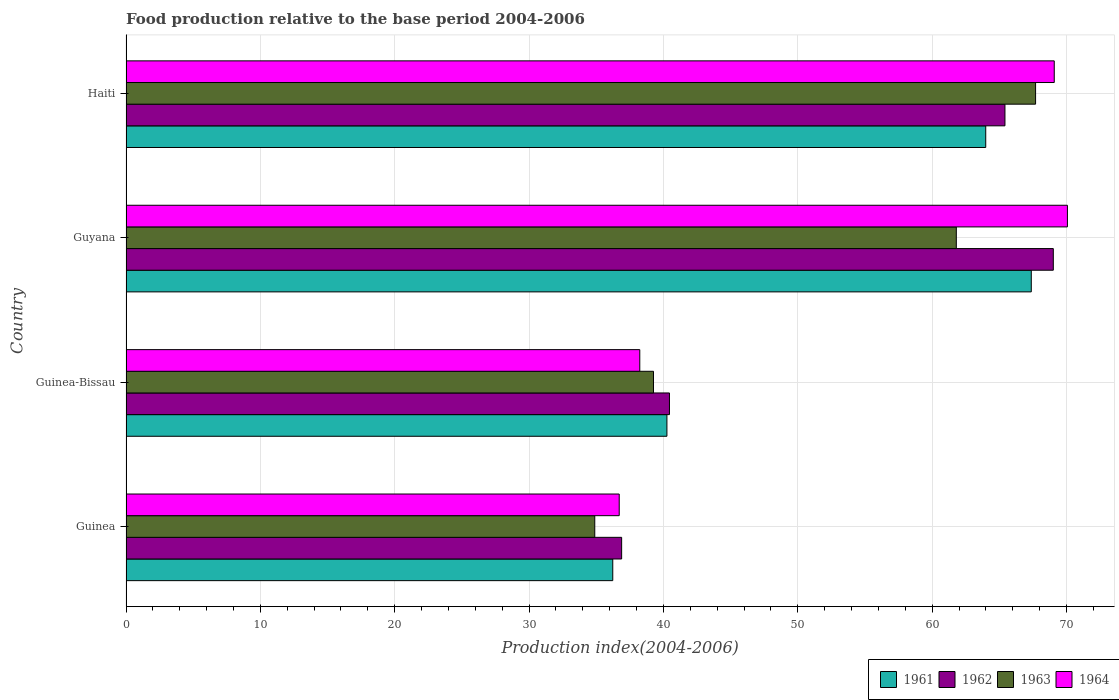How many different coloured bars are there?
Offer a very short reply. 4. How many groups of bars are there?
Your response must be concise. 4. How many bars are there on the 3rd tick from the bottom?
Your answer should be compact. 4. What is the label of the 2nd group of bars from the top?
Offer a terse response. Guyana. What is the food production index in 1963 in Guinea-Bissau?
Provide a succinct answer. 39.26. Across all countries, what is the maximum food production index in 1961?
Provide a short and direct response. 67.38. Across all countries, what is the minimum food production index in 1962?
Provide a short and direct response. 36.89. In which country was the food production index in 1962 maximum?
Offer a terse response. Guyana. In which country was the food production index in 1962 minimum?
Give a very brief answer. Guinea. What is the total food production index in 1962 in the graph?
Provide a succinct answer. 211.78. What is the difference between the food production index in 1964 in Guyana and that in Haiti?
Make the answer very short. 0.98. What is the difference between the food production index in 1964 in Guyana and the food production index in 1963 in Haiti?
Give a very brief answer. 2.37. What is the average food production index in 1962 per country?
Provide a succinct answer. 52.95. What is the difference between the food production index in 1961 and food production index in 1962 in Guinea-Bissau?
Ensure brevity in your answer.  -0.19. In how many countries, is the food production index in 1961 greater than 42 ?
Offer a very short reply. 2. What is the ratio of the food production index in 1962 in Guinea to that in Guinea-Bissau?
Offer a very short reply. 0.91. Is the food production index in 1961 in Guinea-Bissau less than that in Haiti?
Ensure brevity in your answer.  Yes. What is the difference between the highest and the second highest food production index in 1964?
Provide a short and direct response. 0.98. What is the difference between the highest and the lowest food production index in 1963?
Offer a terse response. 32.81. What does the 1st bar from the bottom in Guyana represents?
Offer a very short reply. 1961. Is it the case that in every country, the sum of the food production index in 1963 and food production index in 1961 is greater than the food production index in 1964?
Your response must be concise. Yes. How many bars are there?
Ensure brevity in your answer.  16. How many countries are there in the graph?
Provide a short and direct response. 4. What is the difference between two consecutive major ticks on the X-axis?
Give a very brief answer. 10. Are the values on the major ticks of X-axis written in scientific E-notation?
Provide a short and direct response. No. Does the graph contain any zero values?
Your answer should be compact. No. What is the title of the graph?
Your answer should be compact. Food production relative to the base period 2004-2006. What is the label or title of the X-axis?
Make the answer very short. Production index(2004-2006). What is the label or title of the Y-axis?
Offer a terse response. Country. What is the Production index(2004-2006) of 1961 in Guinea?
Offer a terse response. 36.23. What is the Production index(2004-2006) of 1962 in Guinea?
Your response must be concise. 36.89. What is the Production index(2004-2006) in 1963 in Guinea?
Make the answer very short. 34.89. What is the Production index(2004-2006) of 1964 in Guinea?
Provide a short and direct response. 36.71. What is the Production index(2004-2006) in 1961 in Guinea-Bissau?
Your answer should be compact. 40.26. What is the Production index(2004-2006) of 1962 in Guinea-Bissau?
Give a very brief answer. 40.45. What is the Production index(2004-2006) in 1963 in Guinea-Bissau?
Your answer should be compact. 39.26. What is the Production index(2004-2006) of 1964 in Guinea-Bissau?
Provide a succinct answer. 38.24. What is the Production index(2004-2006) of 1961 in Guyana?
Offer a terse response. 67.38. What is the Production index(2004-2006) of 1962 in Guyana?
Provide a succinct answer. 69.02. What is the Production index(2004-2006) in 1963 in Guyana?
Give a very brief answer. 61.8. What is the Production index(2004-2006) of 1964 in Guyana?
Give a very brief answer. 70.07. What is the Production index(2004-2006) of 1961 in Haiti?
Make the answer very short. 63.99. What is the Production index(2004-2006) of 1962 in Haiti?
Offer a terse response. 65.42. What is the Production index(2004-2006) in 1963 in Haiti?
Make the answer very short. 67.7. What is the Production index(2004-2006) of 1964 in Haiti?
Offer a very short reply. 69.09. Across all countries, what is the maximum Production index(2004-2006) of 1961?
Keep it short and to the point. 67.38. Across all countries, what is the maximum Production index(2004-2006) in 1962?
Provide a succinct answer. 69.02. Across all countries, what is the maximum Production index(2004-2006) in 1963?
Give a very brief answer. 67.7. Across all countries, what is the maximum Production index(2004-2006) in 1964?
Provide a succinct answer. 70.07. Across all countries, what is the minimum Production index(2004-2006) of 1961?
Your answer should be very brief. 36.23. Across all countries, what is the minimum Production index(2004-2006) of 1962?
Provide a short and direct response. 36.89. Across all countries, what is the minimum Production index(2004-2006) of 1963?
Offer a terse response. 34.89. Across all countries, what is the minimum Production index(2004-2006) in 1964?
Ensure brevity in your answer.  36.71. What is the total Production index(2004-2006) of 1961 in the graph?
Your answer should be compact. 207.86. What is the total Production index(2004-2006) of 1962 in the graph?
Provide a short and direct response. 211.78. What is the total Production index(2004-2006) in 1963 in the graph?
Offer a terse response. 203.65. What is the total Production index(2004-2006) of 1964 in the graph?
Your answer should be compact. 214.11. What is the difference between the Production index(2004-2006) in 1961 in Guinea and that in Guinea-Bissau?
Make the answer very short. -4.03. What is the difference between the Production index(2004-2006) of 1962 in Guinea and that in Guinea-Bissau?
Your answer should be compact. -3.56. What is the difference between the Production index(2004-2006) of 1963 in Guinea and that in Guinea-Bissau?
Your response must be concise. -4.37. What is the difference between the Production index(2004-2006) of 1964 in Guinea and that in Guinea-Bissau?
Provide a succinct answer. -1.53. What is the difference between the Production index(2004-2006) in 1961 in Guinea and that in Guyana?
Ensure brevity in your answer.  -31.15. What is the difference between the Production index(2004-2006) in 1962 in Guinea and that in Guyana?
Your answer should be very brief. -32.13. What is the difference between the Production index(2004-2006) of 1963 in Guinea and that in Guyana?
Provide a succinct answer. -26.91. What is the difference between the Production index(2004-2006) of 1964 in Guinea and that in Guyana?
Offer a terse response. -33.36. What is the difference between the Production index(2004-2006) in 1961 in Guinea and that in Haiti?
Make the answer very short. -27.76. What is the difference between the Production index(2004-2006) of 1962 in Guinea and that in Haiti?
Make the answer very short. -28.53. What is the difference between the Production index(2004-2006) in 1963 in Guinea and that in Haiti?
Ensure brevity in your answer.  -32.81. What is the difference between the Production index(2004-2006) of 1964 in Guinea and that in Haiti?
Keep it short and to the point. -32.38. What is the difference between the Production index(2004-2006) in 1961 in Guinea-Bissau and that in Guyana?
Offer a very short reply. -27.12. What is the difference between the Production index(2004-2006) of 1962 in Guinea-Bissau and that in Guyana?
Your answer should be compact. -28.57. What is the difference between the Production index(2004-2006) in 1963 in Guinea-Bissau and that in Guyana?
Ensure brevity in your answer.  -22.54. What is the difference between the Production index(2004-2006) of 1964 in Guinea-Bissau and that in Guyana?
Your response must be concise. -31.83. What is the difference between the Production index(2004-2006) in 1961 in Guinea-Bissau and that in Haiti?
Offer a terse response. -23.73. What is the difference between the Production index(2004-2006) in 1962 in Guinea-Bissau and that in Haiti?
Your answer should be very brief. -24.97. What is the difference between the Production index(2004-2006) of 1963 in Guinea-Bissau and that in Haiti?
Your answer should be compact. -28.44. What is the difference between the Production index(2004-2006) of 1964 in Guinea-Bissau and that in Haiti?
Keep it short and to the point. -30.85. What is the difference between the Production index(2004-2006) of 1961 in Guyana and that in Haiti?
Provide a short and direct response. 3.39. What is the difference between the Production index(2004-2006) of 1963 in Guyana and that in Haiti?
Offer a terse response. -5.9. What is the difference between the Production index(2004-2006) of 1961 in Guinea and the Production index(2004-2006) of 1962 in Guinea-Bissau?
Make the answer very short. -4.22. What is the difference between the Production index(2004-2006) in 1961 in Guinea and the Production index(2004-2006) in 1963 in Guinea-Bissau?
Offer a very short reply. -3.03. What is the difference between the Production index(2004-2006) in 1961 in Guinea and the Production index(2004-2006) in 1964 in Guinea-Bissau?
Keep it short and to the point. -2.01. What is the difference between the Production index(2004-2006) of 1962 in Guinea and the Production index(2004-2006) of 1963 in Guinea-Bissau?
Provide a succinct answer. -2.37. What is the difference between the Production index(2004-2006) in 1962 in Guinea and the Production index(2004-2006) in 1964 in Guinea-Bissau?
Offer a terse response. -1.35. What is the difference between the Production index(2004-2006) in 1963 in Guinea and the Production index(2004-2006) in 1964 in Guinea-Bissau?
Keep it short and to the point. -3.35. What is the difference between the Production index(2004-2006) of 1961 in Guinea and the Production index(2004-2006) of 1962 in Guyana?
Your answer should be very brief. -32.79. What is the difference between the Production index(2004-2006) in 1961 in Guinea and the Production index(2004-2006) in 1963 in Guyana?
Your answer should be compact. -25.57. What is the difference between the Production index(2004-2006) in 1961 in Guinea and the Production index(2004-2006) in 1964 in Guyana?
Give a very brief answer. -33.84. What is the difference between the Production index(2004-2006) in 1962 in Guinea and the Production index(2004-2006) in 1963 in Guyana?
Your answer should be compact. -24.91. What is the difference between the Production index(2004-2006) of 1962 in Guinea and the Production index(2004-2006) of 1964 in Guyana?
Give a very brief answer. -33.18. What is the difference between the Production index(2004-2006) of 1963 in Guinea and the Production index(2004-2006) of 1964 in Guyana?
Offer a terse response. -35.18. What is the difference between the Production index(2004-2006) of 1961 in Guinea and the Production index(2004-2006) of 1962 in Haiti?
Your response must be concise. -29.19. What is the difference between the Production index(2004-2006) of 1961 in Guinea and the Production index(2004-2006) of 1963 in Haiti?
Offer a very short reply. -31.47. What is the difference between the Production index(2004-2006) of 1961 in Guinea and the Production index(2004-2006) of 1964 in Haiti?
Keep it short and to the point. -32.86. What is the difference between the Production index(2004-2006) of 1962 in Guinea and the Production index(2004-2006) of 1963 in Haiti?
Your answer should be very brief. -30.81. What is the difference between the Production index(2004-2006) of 1962 in Guinea and the Production index(2004-2006) of 1964 in Haiti?
Offer a terse response. -32.2. What is the difference between the Production index(2004-2006) in 1963 in Guinea and the Production index(2004-2006) in 1964 in Haiti?
Provide a succinct answer. -34.2. What is the difference between the Production index(2004-2006) of 1961 in Guinea-Bissau and the Production index(2004-2006) of 1962 in Guyana?
Offer a very short reply. -28.76. What is the difference between the Production index(2004-2006) of 1961 in Guinea-Bissau and the Production index(2004-2006) of 1963 in Guyana?
Keep it short and to the point. -21.54. What is the difference between the Production index(2004-2006) of 1961 in Guinea-Bissau and the Production index(2004-2006) of 1964 in Guyana?
Offer a very short reply. -29.81. What is the difference between the Production index(2004-2006) in 1962 in Guinea-Bissau and the Production index(2004-2006) in 1963 in Guyana?
Make the answer very short. -21.35. What is the difference between the Production index(2004-2006) in 1962 in Guinea-Bissau and the Production index(2004-2006) in 1964 in Guyana?
Ensure brevity in your answer.  -29.62. What is the difference between the Production index(2004-2006) in 1963 in Guinea-Bissau and the Production index(2004-2006) in 1964 in Guyana?
Your response must be concise. -30.81. What is the difference between the Production index(2004-2006) in 1961 in Guinea-Bissau and the Production index(2004-2006) in 1962 in Haiti?
Your response must be concise. -25.16. What is the difference between the Production index(2004-2006) of 1961 in Guinea-Bissau and the Production index(2004-2006) of 1963 in Haiti?
Your answer should be compact. -27.44. What is the difference between the Production index(2004-2006) of 1961 in Guinea-Bissau and the Production index(2004-2006) of 1964 in Haiti?
Ensure brevity in your answer.  -28.83. What is the difference between the Production index(2004-2006) of 1962 in Guinea-Bissau and the Production index(2004-2006) of 1963 in Haiti?
Your answer should be very brief. -27.25. What is the difference between the Production index(2004-2006) of 1962 in Guinea-Bissau and the Production index(2004-2006) of 1964 in Haiti?
Your answer should be compact. -28.64. What is the difference between the Production index(2004-2006) of 1963 in Guinea-Bissau and the Production index(2004-2006) of 1964 in Haiti?
Offer a very short reply. -29.83. What is the difference between the Production index(2004-2006) in 1961 in Guyana and the Production index(2004-2006) in 1962 in Haiti?
Ensure brevity in your answer.  1.96. What is the difference between the Production index(2004-2006) in 1961 in Guyana and the Production index(2004-2006) in 1963 in Haiti?
Make the answer very short. -0.32. What is the difference between the Production index(2004-2006) in 1961 in Guyana and the Production index(2004-2006) in 1964 in Haiti?
Offer a very short reply. -1.71. What is the difference between the Production index(2004-2006) in 1962 in Guyana and the Production index(2004-2006) in 1963 in Haiti?
Ensure brevity in your answer.  1.32. What is the difference between the Production index(2004-2006) of 1962 in Guyana and the Production index(2004-2006) of 1964 in Haiti?
Give a very brief answer. -0.07. What is the difference between the Production index(2004-2006) in 1963 in Guyana and the Production index(2004-2006) in 1964 in Haiti?
Provide a succinct answer. -7.29. What is the average Production index(2004-2006) of 1961 per country?
Your response must be concise. 51.97. What is the average Production index(2004-2006) in 1962 per country?
Offer a terse response. 52.95. What is the average Production index(2004-2006) of 1963 per country?
Give a very brief answer. 50.91. What is the average Production index(2004-2006) of 1964 per country?
Keep it short and to the point. 53.53. What is the difference between the Production index(2004-2006) of 1961 and Production index(2004-2006) of 1962 in Guinea?
Keep it short and to the point. -0.66. What is the difference between the Production index(2004-2006) of 1961 and Production index(2004-2006) of 1963 in Guinea?
Your answer should be compact. 1.34. What is the difference between the Production index(2004-2006) of 1961 and Production index(2004-2006) of 1964 in Guinea?
Make the answer very short. -0.48. What is the difference between the Production index(2004-2006) in 1962 and Production index(2004-2006) in 1964 in Guinea?
Make the answer very short. 0.18. What is the difference between the Production index(2004-2006) of 1963 and Production index(2004-2006) of 1964 in Guinea?
Your answer should be compact. -1.82. What is the difference between the Production index(2004-2006) in 1961 and Production index(2004-2006) in 1962 in Guinea-Bissau?
Your answer should be very brief. -0.19. What is the difference between the Production index(2004-2006) in 1961 and Production index(2004-2006) in 1963 in Guinea-Bissau?
Ensure brevity in your answer.  1. What is the difference between the Production index(2004-2006) of 1961 and Production index(2004-2006) of 1964 in Guinea-Bissau?
Give a very brief answer. 2.02. What is the difference between the Production index(2004-2006) in 1962 and Production index(2004-2006) in 1963 in Guinea-Bissau?
Your answer should be compact. 1.19. What is the difference between the Production index(2004-2006) in 1962 and Production index(2004-2006) in 1964 in Guinea-Bissau?
Ensure brevity in your answer.  2.21. What is the difference between the Production index(2004-2006) in 1961 and Production index(2004-2006) in 1962 in Guyana?
Offer a terse response. -1.64. What is the difference between the Production index(2004-2006) in 1961 and Production index(2004-2006) in 1963 in Guyana?
Provide a succinct answer. 5.58. What is the difference between the Production index(2004-2006) of 1961 and Production index(2004-2006) of 1964 in Guyana?
Provide a short and direct response. -2.69. What is the difference between the Production index(2004-2006) of 1962 and Production index(2004-2006) of 1963 in Guyana?
Keep it short and to the point. 7.22. What is the difference between the Production index(2004-2006) of 1962 and Production index(2004-2006) of 1964 in Guyana?
Your answer should be compact. -1.05. What is the difference between the Production index(2004-2006) in 1963 and Production index(2004-2006) in 1964 in Guyana?
Offer a very short reply. -8.27. What is the difference between the Production index(2004-2006) in 1961 and Production index(2004-2006) in 1962 in Haiti?
Ensure brevity in your answer.  -1.43. What is the difference between the Production index(2004-2006) in 1961 and Production index(2004-2006) in 1963 in Haiti?
Provide a short and direct response. -3.71. What is the difference between the Production index(2004-2006) in 1961 and Production index(2004-2006) in 1964 in Haiti?
Offer a terse response. -5.1. What is the difference between the Production index(2004-2006) of 1962 and Production index(2004-2006) of 1963 in Haiti?
Give a very brief answer. -2.28. What is the difference between the Production index(2004-2006) in 1962 and Production index(2004-2006) in 1964 in Haiti?
Your answer should be compact. -3.67. What is the difference between the Production index(2004-2006) in 1963 and Production index(2004-2006) in 1964 in Haiti?
Provide a short and direct response. -1.39. What is the ratio of the Production index(2004-2006) of 1961 in Guinea to that in Guinea-Bissau?
Provide a short and direct response. 0.9. What is the ratio of the Production index(2004-2006) in 1962 in Guinea to that in Guinea-Bissau?
Offer a terse response. 0.91. What is the ratio of the Production index(2004-2006) of 1963 in Guinea to that in Guinea-Bissau?
Your answer should be very brief. 0.89. What is the ratio of the Production index(2004-2006) of 1964 in Guinea to that in Guinea-Bissau?
Provide a succinct answer. 0.96. What is the ratio of the Production index(2004-2006) in 1961 in Guinea to that in Guyana?
Your answer should be compact. 0.54. What is the ratio of the Production index(2004-2006) of 1962 in Guinea to that in Guyana?
Provide a short and direct response. 0.53. What is the ratio of the Production index(2004-2006) of 1963 in Guinea to that in Guyana?
Keep it short and to the point. 0.56. What is the ratio of the Production index(2004-2006) of 1964 in Guinea to that in Guyana?
Ensure brevity in your answer.  0.52. What is the ratio of the Production index(2004-2006) in 1961 in Guinea to that in Haiti?
Give a very brief answer. 0.57. What is the ratio of the Production index(2004-2006) in 1962 in Guinea to that in Haiti?
Ensure brevity in your answer.  0.56. What is the ratio of the Production index(2004-2006) in 1963 in Guinea to that in Haiti?
Give a very brief answer. 0.52. What is the ratio of the Production index(2004-2006) in 1964 in Guinea to that in Haiti?
Give a very brief answer. 0.53. What is the ratio of the Production index(2004-2006) in 1961 in Guinea-Bissau to that in Guyana?
Provide a short and direct response. 0.6. What is the ratio of the Production index(2004-2006) of 1962 in Guinea-Bissau to that in Guyana?
Provide a succinct answer. 0.59. What is the ratio of the Production index(2004-2006) of 1963 in Guinea-Bissau to that in Guyana?
Make the answer very short. 0.64. What is the ratio of the Production index(2004-2006) in 1964 in Guinea-Bissau to that in Guyana?
Make the answer very short. 0.55. What is the ratio of the Production index(2004-2006) in 1961 in Guinea-Bissau to that in Haiti?
Keep it short and to the point. 0.63. What is the ratio of the Production index(2004-2006) in 1962 in Guinea-Bissau to that in Haiti?
Provide a succinct answer. 0.62. What is the ratio of the Production index(2004-2006) in 1963 in Guinea-Bissau to that in Haiti?
Offer a terse response. 0.58. What is the ratio of the Production index(2004-2006) of 1964 in Guinea-Bissau to that in Haiti?
Your answer should be very brief. 0.55. What is the ratio of the Production index(2004-2006) in 1961 in Guyana to that in Haiti?
Offer a terse response. 1.05. What is the ratio of the Production index(2004-2006) of 1962 in Guyana to that in Haiti?
Your answer should be very brief. 1.05. What is the ratio of the Production index(2004-2006) of 1963 in Guyana to that in Haiti?
Provide a short and direct response. 0.91. What is the ratio of the Production index(2004-2006) of 1964 in Guyana to that in Haiti?
Provide a short and direct response. 1.01. What is the difference between the highest and the second highest Production index(2004-2006) of 1961?
Make the answer very short. 3.39. What is the difference between the highest and the second highest Production index(2004-2006) in 1964?
Provide a succinct answer. 0.98. What is the difference between the highest and the lowest Production index(2004-2006) of 1961?
Keep it short and to the point. 31.15. What is the difference between the highest and the lowest Production index(2004-2006) in 1962?
Your response must be concise. 32.13. What is the difference between the highest and the lowest Production index(2004-2006) in 1963?
Provide a short and direct response. 32.81. What is the difference between the highest and the lowest Production index(2004-2006) of 1964?
Ensure brevity in your answer.  33.36. 